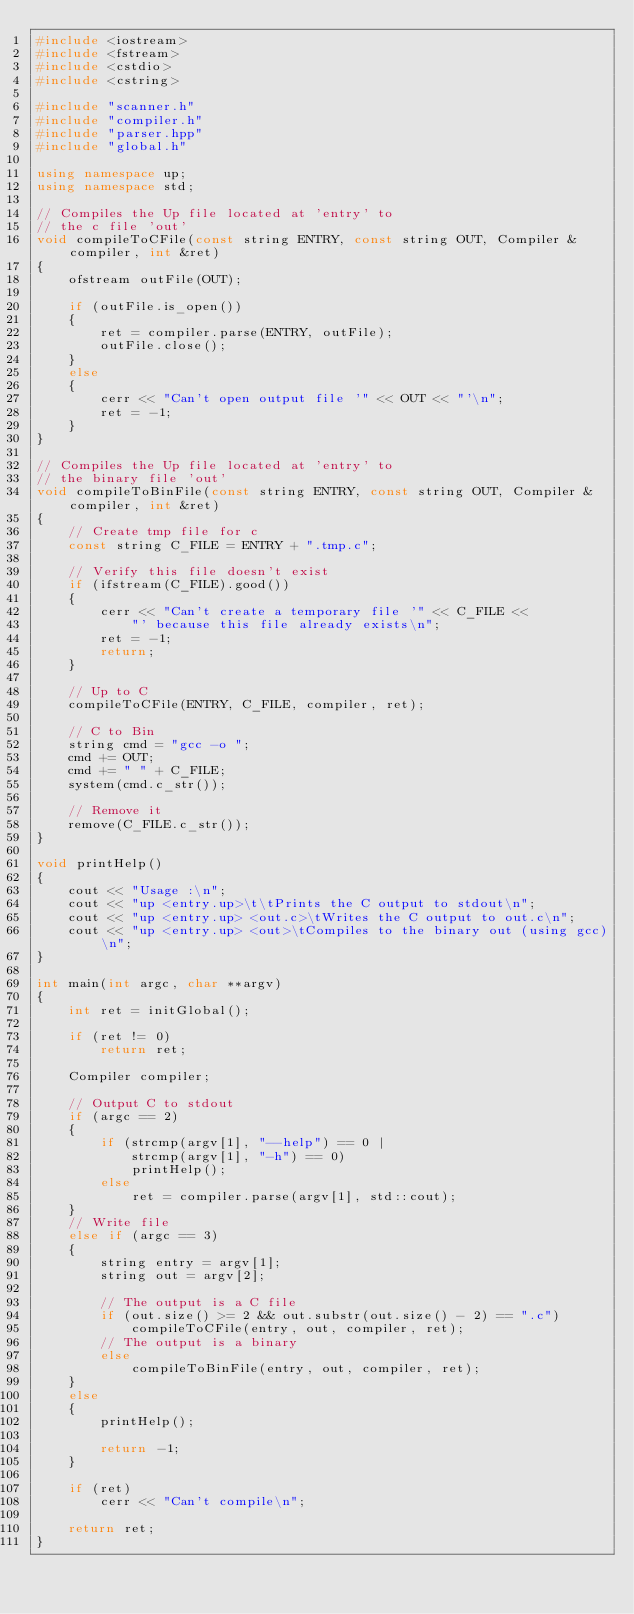<code> <loc_0><loc_0><loc_500><loc_500><_C++_>#include <iostream>
#include <fstream>
#include <cstdio>
#include <cstring>

#include "scanner.h"
#include "compiler.h"
#include "parser.hpp"
#include "global.h"

using namespace up;
using namespace std;

// Compiles the Up file located at 'entry' to
// the c file 'out'
void compileToCFile(const string ENTRY, const string OUT, Compiler &compiler, int &ret)
{
    ofstream outFile(OUT);

    if (outFile.is_open())
    {
        ret = compiler.parse(ENTRY, outFile);
        outFile.close();
    }
    else
    {
        cerr << "Can't open output file '" << OUT << "'\n";
        ret = -1;
    }
}

// Compiles the Up file located at 'entry' to
// the binary file 'out'
void compileToBinFile(const string ENTRY, const string OUT, Compiler &compiler, int &ret)
{
    // Create tmp file for c
    const string C_FILE = ENTRY + ".tmp.c";

    // Verify this file doesn't exist
    if (ifstream(C_FILE).good())
    {
        cerr << "Can't create a temporary file '" << C_FILE <<
            "' because this file already exists\n";
        ret = -1;
        return;
    }
    
    // Up to C
    compileToCFile(ENTRY, C_FILE, compiler, ret);
    
    // C to Bin
    string cmd = "gcc -o ";
    cmd += OUT;
    cmd += " " + C_FILE;
    system(cmd.c_str());

    // Remove it
    remove(C_FILE.c_str());
}

void printHelp()
{
    cout << "Usage :\n";
    cout << "up <entry.up>\t\tPrints the C output to stdout\n";
    cout << "up <entry.up> <out.c>\tWrites the C output to out.c\n";
    cout << "up <entry.up> <out>\tCompiles to the binary out (using gcc)\n";
}

int main(int argc, char **argv)
{
    int ret = initGlobal();

    if (ret != 0)
        return ret;

    Compiler compiler;

    // Output C to stdout
    if (argc == 2)
    {
        if (strcmp(argv[1], "--help") == 0 |
            strcmp(argv[1], "-h") == 0)
            printHelp();
        else
            ret = compiler.parse(argv[1], std::cout);
    }
    // Write file
    else if (argc == 3)
    {
        string entry = argv[1];
        string out = argv[2];

        // The output is a C file
        if (out.size() >= 2 && out.substr(out.size() - 2) == ".c")
            compileToCFile(entry, out, compiler, ret);
        // The output is a binary
        else
            compileToBinFile(entry, out, compiler, ret);
    }
    else
    {
        printHelp();

        return -1;
    }

    if (ret)
        cerr << "Can't compile\n";

    return ret;
}
</code> 